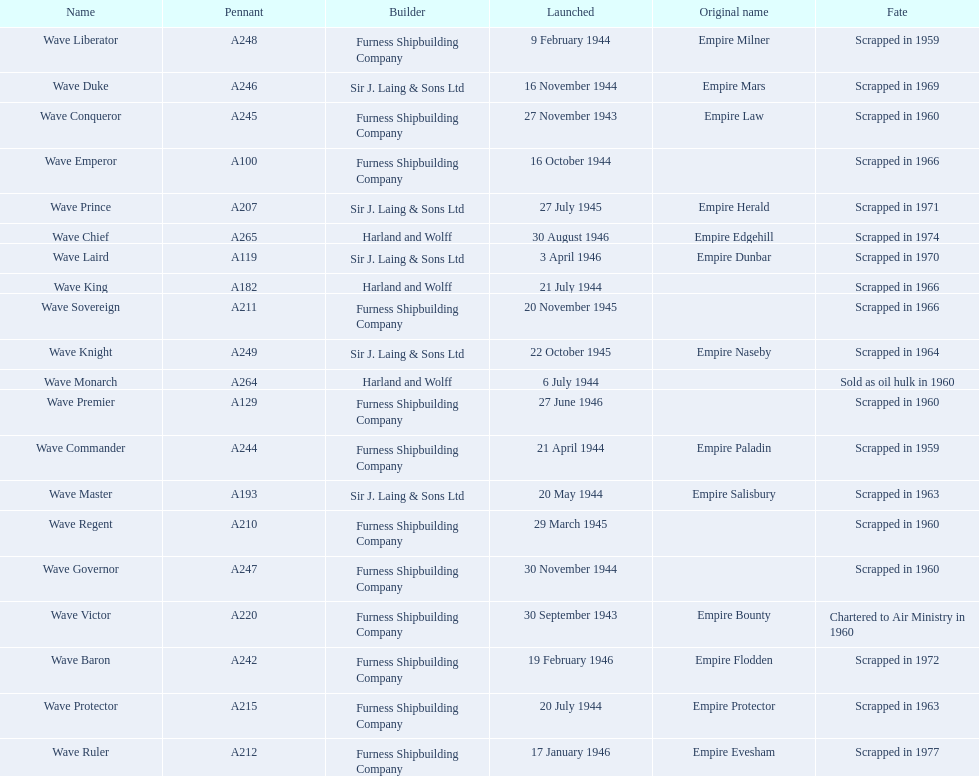What date was the wave victor launched? 30 September 1943. What other oiler was launched that same year? Wave Conqueror. 